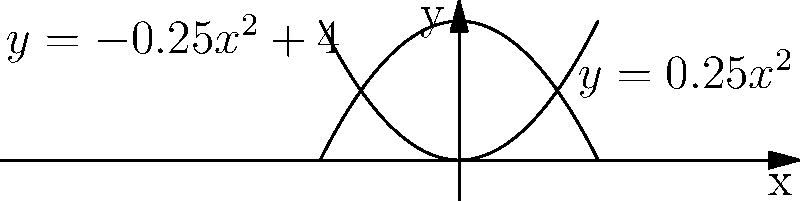As a counselor helping a student overcome their fear of needles, you might use visual aids to distract them during treatment. Consider the graph shown above. What type of conic section is represented by the intersection of the two curves, and how might this relate to helping the student focus on something other than their fear? To identify the type of conic section and relate it to the counseling scenario, let's follow these steps:

1) First, observe the two curves:
   - The upper curve is a downward-facing parabola: $y = -0.25x^2 + 4$
   - The lower curve is an upward-facing parabola: $y = 0.25x^2$

2) The intersection of these two curves forms the conic section we're interested in.

3) When two parabolas intersect in this manner (one opening upward and one downward), they form an ellipse.

4) We can verify this mathematically:
   - At the points of intersection: $-0.25x^2 + 4 = 0.25x^2$
   - Simplifying: $4 = 0.5x^2$
   - Solving for x: $x = \pm 2\sqrt{2}$

   This gives us the width of the ellipse. The height can be found by plugging these x-values into either equation.

5) In the context of counseling:
   - The ellipse shape could be used as a focusing point for the student.
   - You could ask the student to trace the shape with their eyes or finger.
   - This visual and tactile exercise can serve as a distraction technique during needle procedures.
   - The symmetry and closed nature of the ellipse can also represent the idea of a complete, contained experience, potentially helping to bound the student's anxiety.

By using this mathematical concept as a therapeutic tool, you're combining analytical thinking with practical counseling techniques, potentially making the coping strategy more engaging for some students.
Answer: Ellipse 